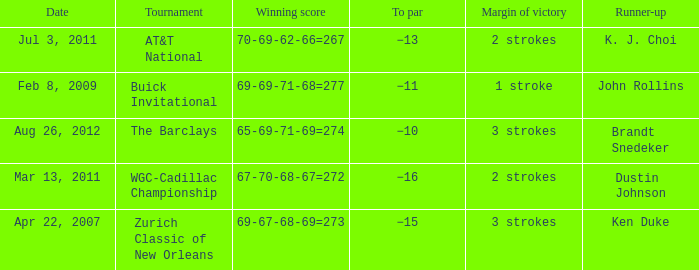A tournament on which date has a margin of victory of 2 strokes and a par of −16? Mar 13, 2011. 